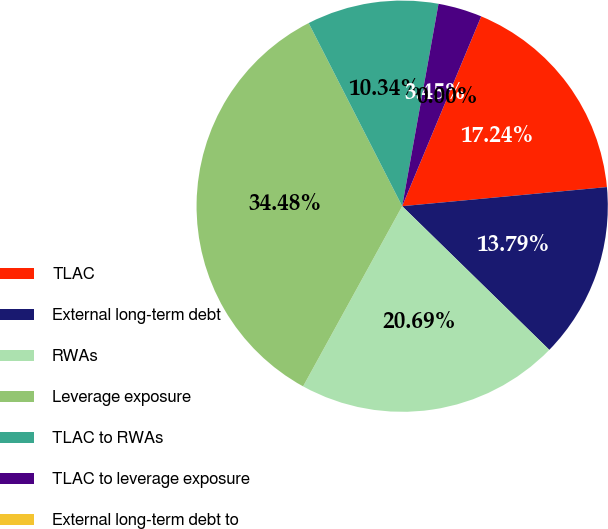Convert chart. <chart><loc_0><loc_0><loc_500><loc_500><pie_chart><fcel>TLAC<fcel>External long-term debt<fcel>RWAs<fcel>Leverage exposure<fcel>TLAC to RWAs<fcel>TLAC to leverage exposure<fcel>External long-term debt to<nl><fcel>17.24%<fcel>13.79%<fcel>20.69%<fcel>34.48%<fcel>10.34%<fcel>3.45%<fcel>0.0%<nl></chart> 